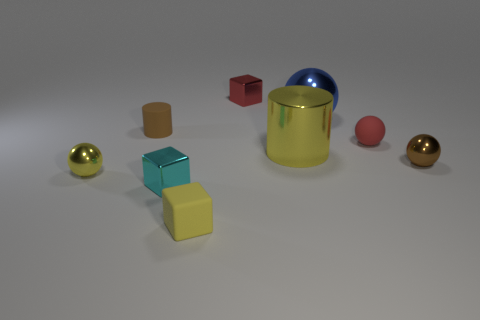Are there more rubber objects than big objects?
Keep it short and to the point. Yes. Does the matte block have the same size as the yellow shiny cylinder?
Give a very brief answer. No. What number of objects are either small blue rubber cubes or tiny shiny balls?
Provide a succinct answer. 2. What is the shape of the brown thing that is behind the tiny matte object that is right of the red object that is behind the small cylinder?
Ensure brevity in your answer.  Cylinder. Does the tiny brown thing that is in front of the tiny matte cylinder have the same material as the red object in front of the blue metal thing?
Provide a succinct answer. No. There is a small brown object that is the same shape as the blue metal thing; what material is it?
Offer a terse response. Metal. There is a small matte thing in front of the small cyan metallic object; is it the same shape as the small red thing that is left of the large metal cylinder?
Your answer should be compact. Yes. Is the number of cylinders on the left side of the small red metallic block less than the number of objects behind the tiny cyan metallic cube?
Your answer should be very brief. Yes. How many other objects are there of the same shape as the cyan shiny object?
Make the answer very short. 2. What is the shape of the big yellow thing that is made of the same material as the small cyan cube?
Your answer should be compact. Cylinder. 